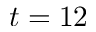Convert formula to latex. <formula><loc_0><loc_0><loc_500><loc_500>t = 1 2</formula> 